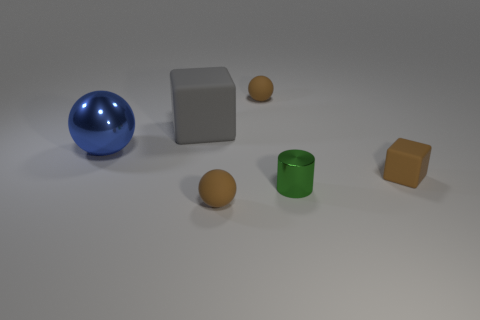How many green things are balls or large blocks?
Offer a terse response. 0. What number of other objects are there of the same material as the blue ball?
Provide a succinct answer. 1. Do the tiny brown thing behind the large gray thing and the blue metal thing have the same shape?
Keep it short and to the point. Yes. Are there any large red shiny blocks?
Your answer should be very brief. No. Is there any other thing that has the same shape as the large rubber object?
Provide a short and direct response. Yes. Is the number of big blue balls on the left side of the blue ball greater than the number of objects?
Give a very brief answer. No. Are there any small green cylinders in front of the cylinder?
Offer a very short reply. No. Do the blue shiny object and the cylinder have the same size?
Keep it short and to the point. No. There is another object that is the same shape as the big gray thing; what is its size?
Offer a very short reply. Small. The small sphere in front of the small brown object that is on the right side of the tiny metal cylinder is made of what material?
Provide a succinct answer. Rubber. 